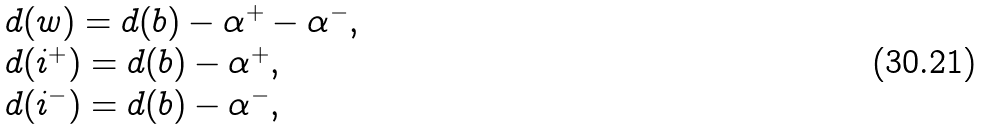Convert formula to latex. <formula><loc_0><loc_0><loc_500><loc_500>\begin{array} { l } d ( w ) = d ( b ) - \alpha ^ { + } - \alpha ^ { - } , \\ d ( i ^ { + } ) = d ( b ) - \alpha ^ { + } , \\ d ( i ^ { - } ) = d ( b ) - \alpha ^ { - } , \end{array}</formula> 